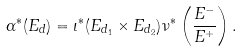Convert formula to latex. <formula><loc_0><loc_0><loc_500><loc_500>\alpha ^ { * } ( E _ { d } ) = \iota ^ { * } ( E _ { d _ { 1 } } \times E _ { d _ { 2 } } ) \nu ^ { * } \left ( \frac { E ^ { - } } { E ^ { + } } \right ) .</formula> 